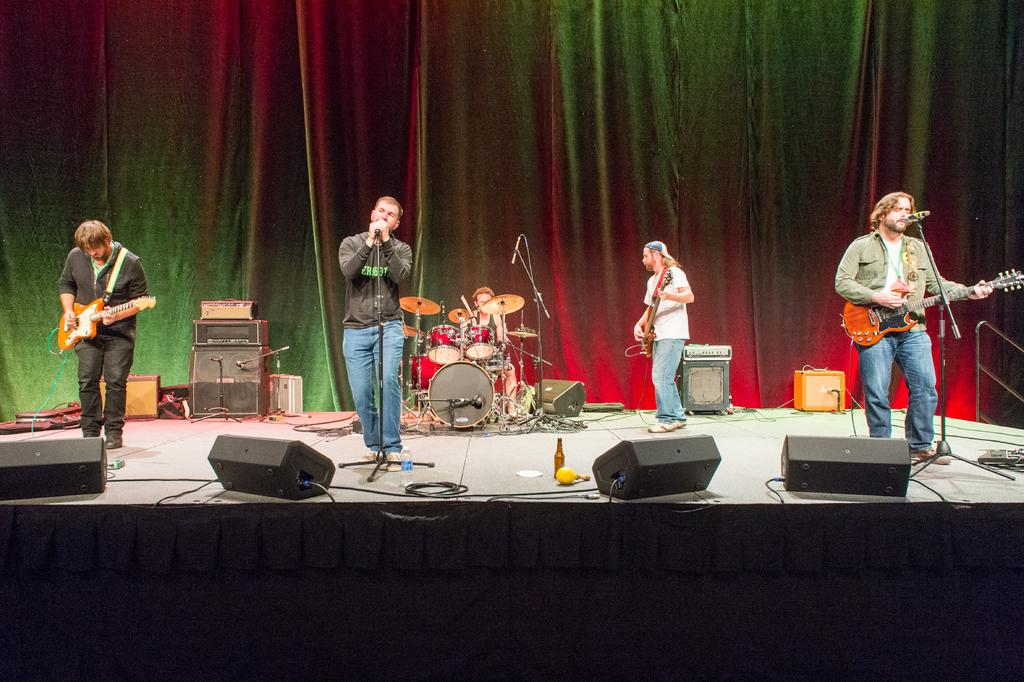What are the two persons in the image doing? The two persons in the image are playing the guitar. What is the third person in the image doing? The third person in the image is singing a song. Can you tell me how many persons are skating in the image? There are no persons skating in the image; the focus is on the persons playing the guitar and singing a song. What type of journey is depicted in the image? There is no journey depicted in the image; it features a scene of musical performance. 